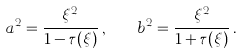Convert formula to latex. <formula><loc_0><loc_0><loc_500><loc_500>a ^ { 2 } = \frac { \xi ^ { 2 } } { 1 - \tau ( \xi ) } \, , \quad b ^ { 2 } = \frac { \xi ^ { 2 } } { 1 + \tau ( \xi ) } \, .</formula> 